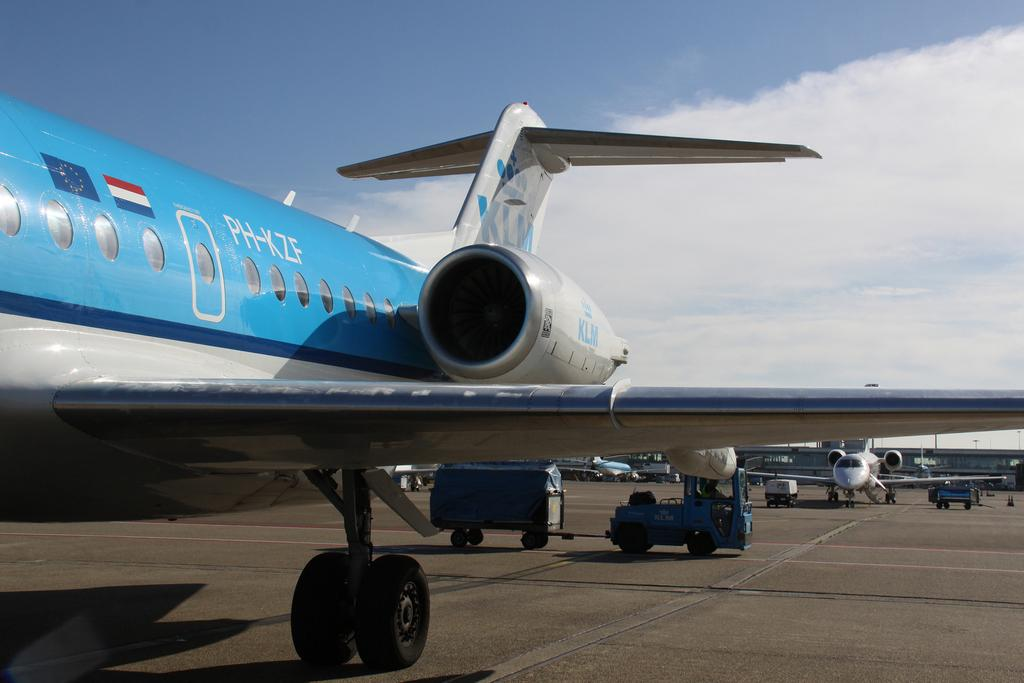<image>
Create a compact narrative representing the image presented. A blue and silver passenger plane with the letters PH-KZF printed on its side. 